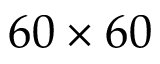Convert formula to latex. <formula><loc_0><loc_0><loc_500><loc_500>6 0 \times 6 0</formula> 